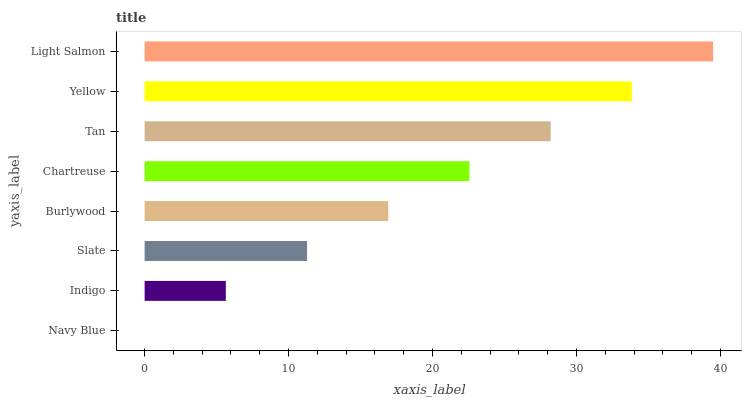Is Navy Blue the minimum?
Answer yes or no. Yes. Is Light Salmon the maximum?
Answer yes or no. Yes. Is Indigo the minimum?
Answer yes or no. No. Is Indigo the maximum?
Answer yes or no. No. Is Indigo greater than Navy Blue?
Answer yes or no. Yes. Is Navy Blue less than Indigo?
Answer yes or no. Yes. Is Navy Blue greater than Indigo?
Answer yes or no. No. Is Indigo less than Navy Blue?
Answer yes or no. No. Is Chartreuse the high median?
Answer yes or no. Yes. Is Burlywood the low median?
Answer yes or no. Yes. Is Indigo the high median?
Answer yes or no. No. Is Light Salmon the low median?
Answer yes or no. No. 